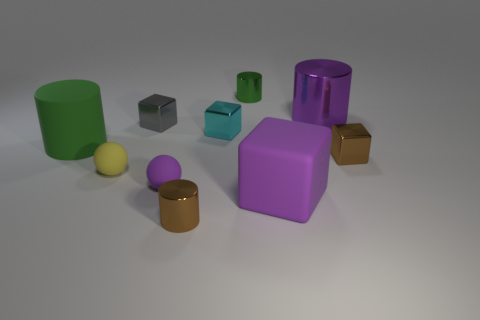How many green cylinders must be subtracted to get 1 green cylinders? 1 Subtract 1 cylinders. How many cylinders are left? 3 Subtract all spheres. How many objects are left? 8 Subtract 1 green cylinders. How many objects are left? 9 Subtract all blue metal cubes. Subtract all purple shiny cylinders. How many objects are left? 9 Add 2 blocks. How many blocks are left? 6 Add 2 tiny brown shiny cylinders. How many tiny brown shiny cylinders exist? 3 